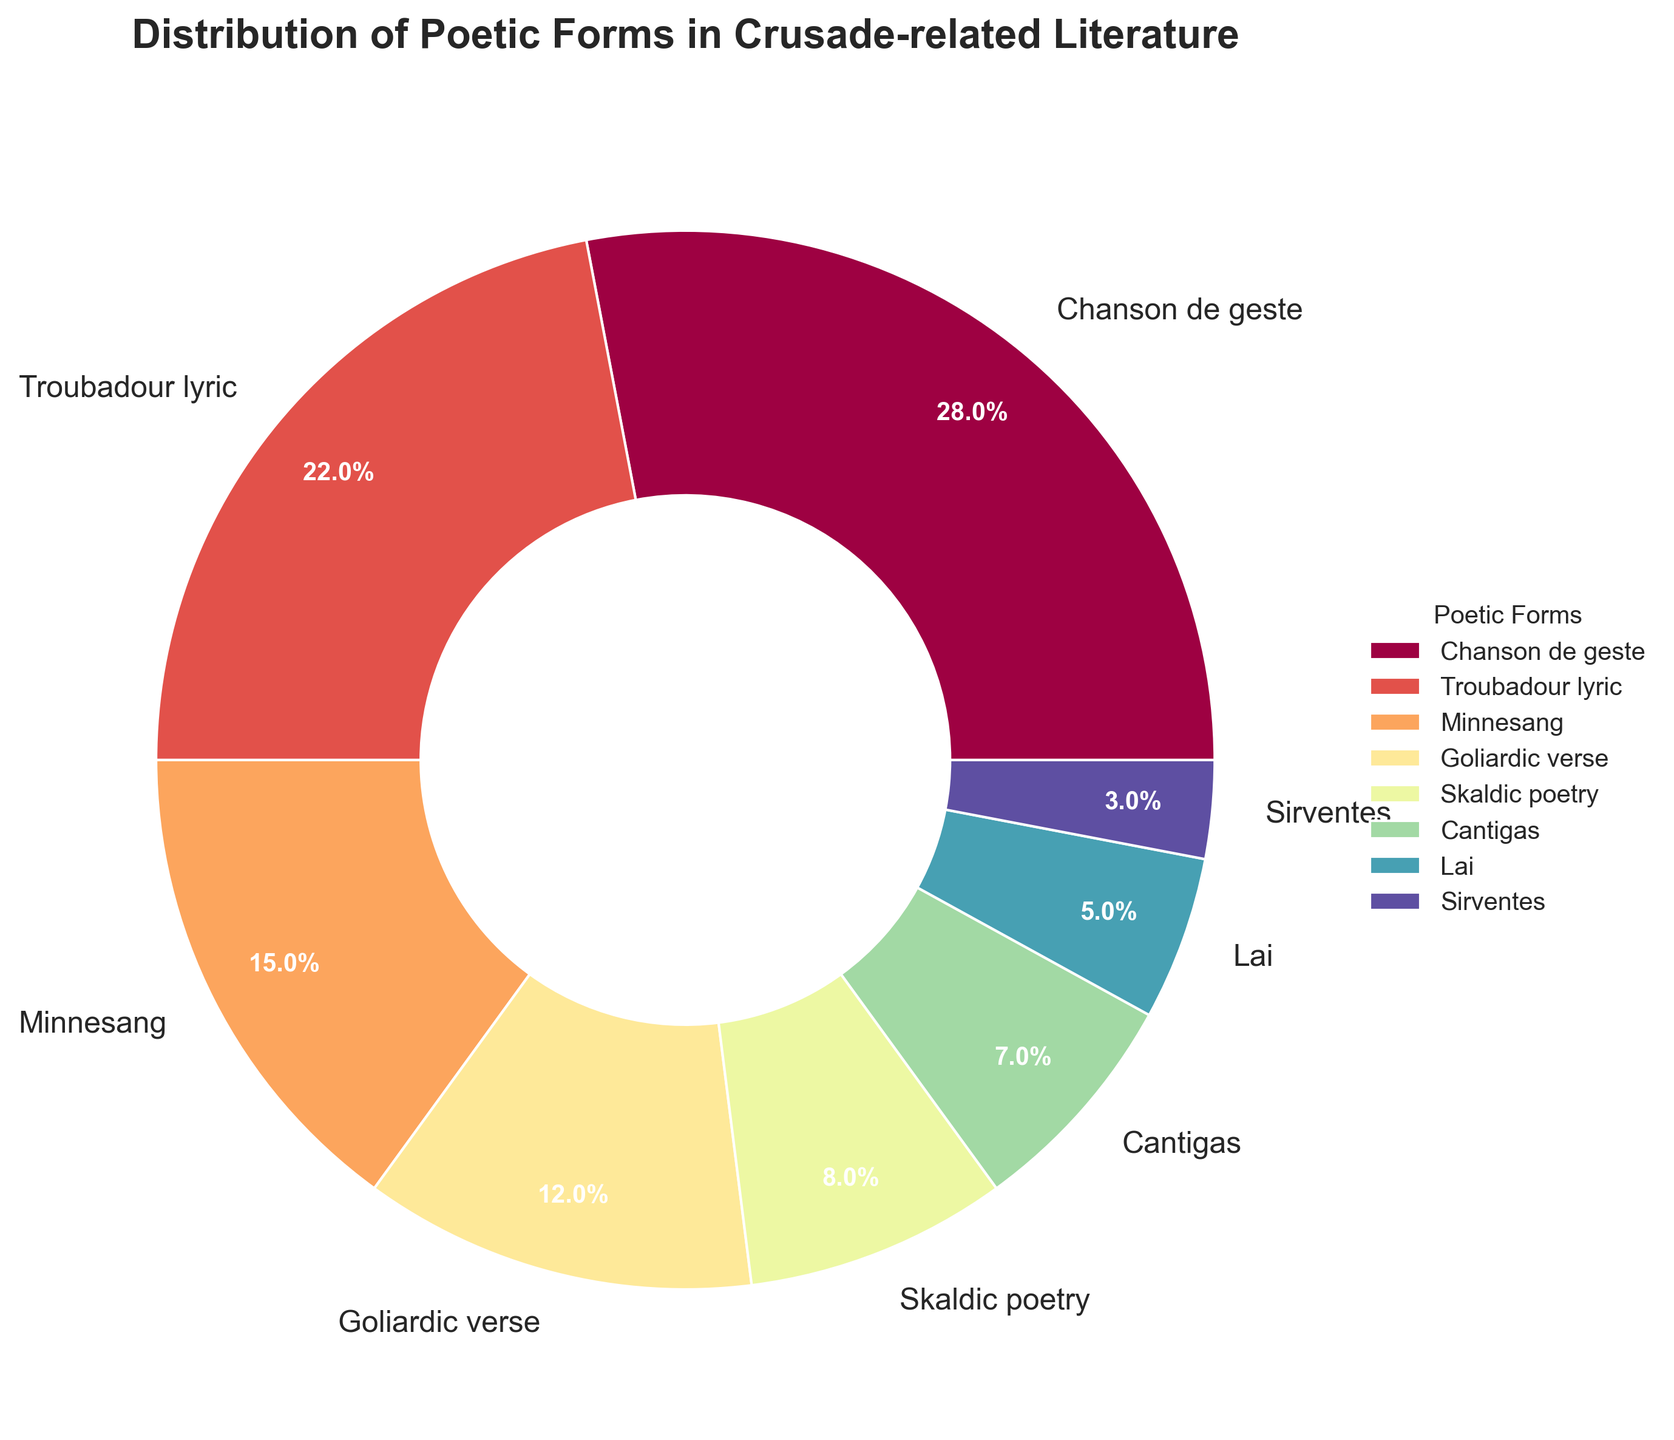What's the most common poetic form used in Crusade-related literature? The chart shows several poetic forms with their respective percentages. The largest wedge represents "Chanson de geste" with 28%.
Answer: Chanson de geste Which two poetic forms together constitute more than 50% of the distribution? Identifying the largest portions, "Chanson de geste" (28%) and "Troubadour lyric" (22%) together add up to 28% + 22% = 50%.
Answer: Chanson de geste and Troubadour lyric How much larger in percentage is Minnesang compared to Sirventes? The chart shows Minnesang at 15% and Sirventes at 3%. The difference is 15% - 3% = 12%.
Answer: 12% What is the combined percentage of Skaldic poetry, Cantigas, and Lai? Adding the respective percentages from the chart: Skaldic poetry (8%), Cantigas (7%), and Lai (5%) gives 8% + 7% + 5% = 20%.
Answer: 20% What is the least common poetic form in the distribution? The chart indicates that the smallest wedge, representing 3%, is "Sirventes".
Answer: Sirventes How does the percentage of Goliardic verse compare to Minnesang? Goliardic verse is shown as 12%, while Minnesang is 15%. Minnesang is greater than Goliardic verse.
Answer: Minnesang is greater than Goliardic verse What portion of the chart consists of poetic forms other than Chanson de geste and Troubadour lyric? The semi-circle representing Chanson de geste (28%) and Troubadour lyric (22%) equals 50%, so the rest is 100% - 50% = 50%.
Answer: 50% Which poetic forms have a percentage between 5% and 15%? Referring to the chart, Minnesang (15%), Goliardic verse (12%), Skaldic poetry (8%), and Cantigas (7%) fall within this range.
Answer: Minnesang, Goliardic verse, Skaldic poetry, and Cantigas What is the average percentage of Minnesang, Goliardic verse, and Cantigas? Add Minnesang (15%), Goliardic verse (12%), and Cantigas (7%), and divide by 3 to get (15 + 12 + 7) / 3 = 11.33%.
Answer: 11.33% Are there any poetic forms with an equal percentage? Reviewing the chart, no two poetic forms have the exact same percentage. Each has a unique value.
Answer: No 